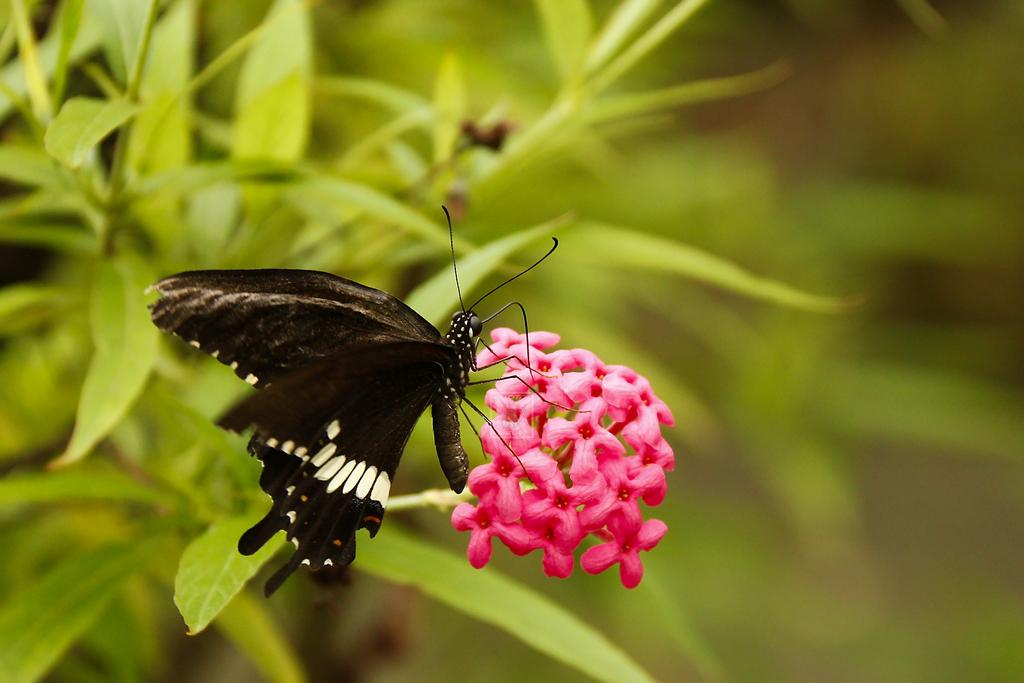What is present in the image? There is an insect in the image. Where is the insect located? The insect is sitting on a flower. What colors can be seen on the insect? The insect has black and white coloring. What type of railway can be seen in the image? There is no railway present in the image; it features an insect sitting on a flower. What role does the copper play in the image? There is no copper present in the image. 